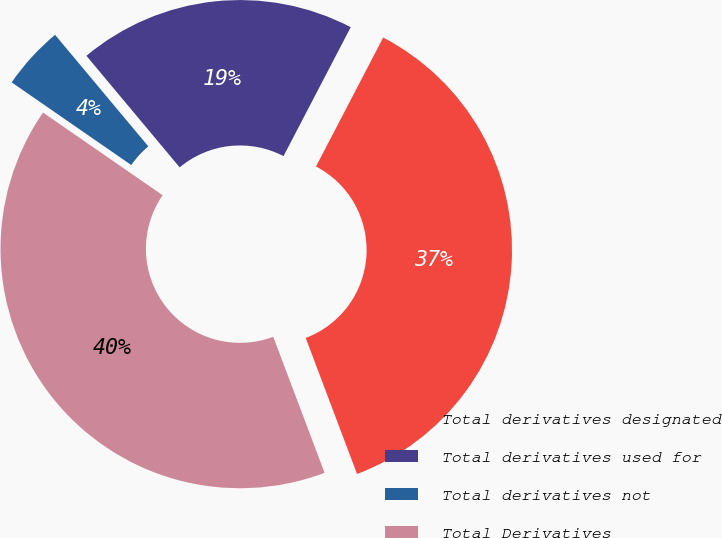Convert chart to OTSL. <chart><loc_0><loc_0><loc_500><loc_500><pie_chart><fcel>Total derivatives designated<fcel>Total derivatives used for<fcel>Total derivatives not<fcel>Total Derivatives<nl><fcel>36.61%<fcel>18.73%<fcel>4.29%<fcel>40.37%<nl></chart> 